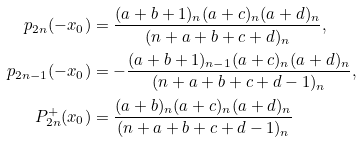<formula> <loc_0><loc_0><loc_500><loc_500>p _ { 2 n } ( - x _ { 0 } ) & = \frac { ( a + b + 1 ) _ { n } ( a + c ) _ { n } ( a + d ) _ { n } } { ( n + a + b + c + d ) _ { n } } , \\ p _ { 2 n - 1 } ( - x _ { 0 } ) & = - \frac { ( a + b + 1 ) _ { n - 1 } ( a + c ) _ { n } ( a + d ) _ { n } } { ( n + a + b + c + d - 1 ) _ { n } } , \\ P _ { 2 n } ^ { + } ( x _ { 0 } ) & = \frac { ( a + b ) _ { n } ( a + c ) _ { n } ( a + d ) _ { n } } { ( n + a + b + c + d - 1 ) _ { n } }</formula> 